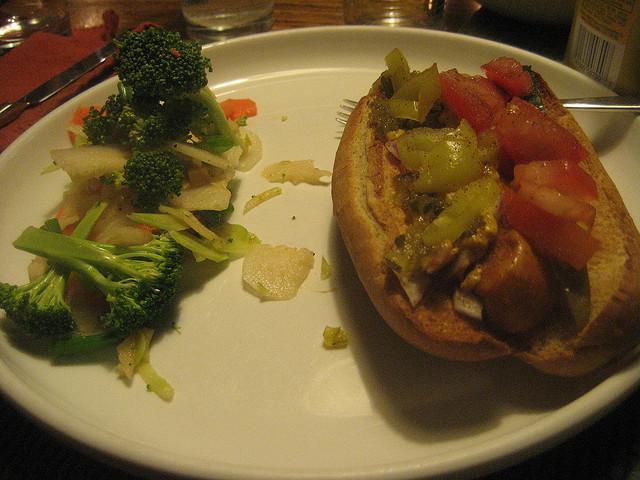How many meat products are on the plate?
Give a very brief answer. 1. How many broccolis can you see?
Give a very brief answer. 4. 